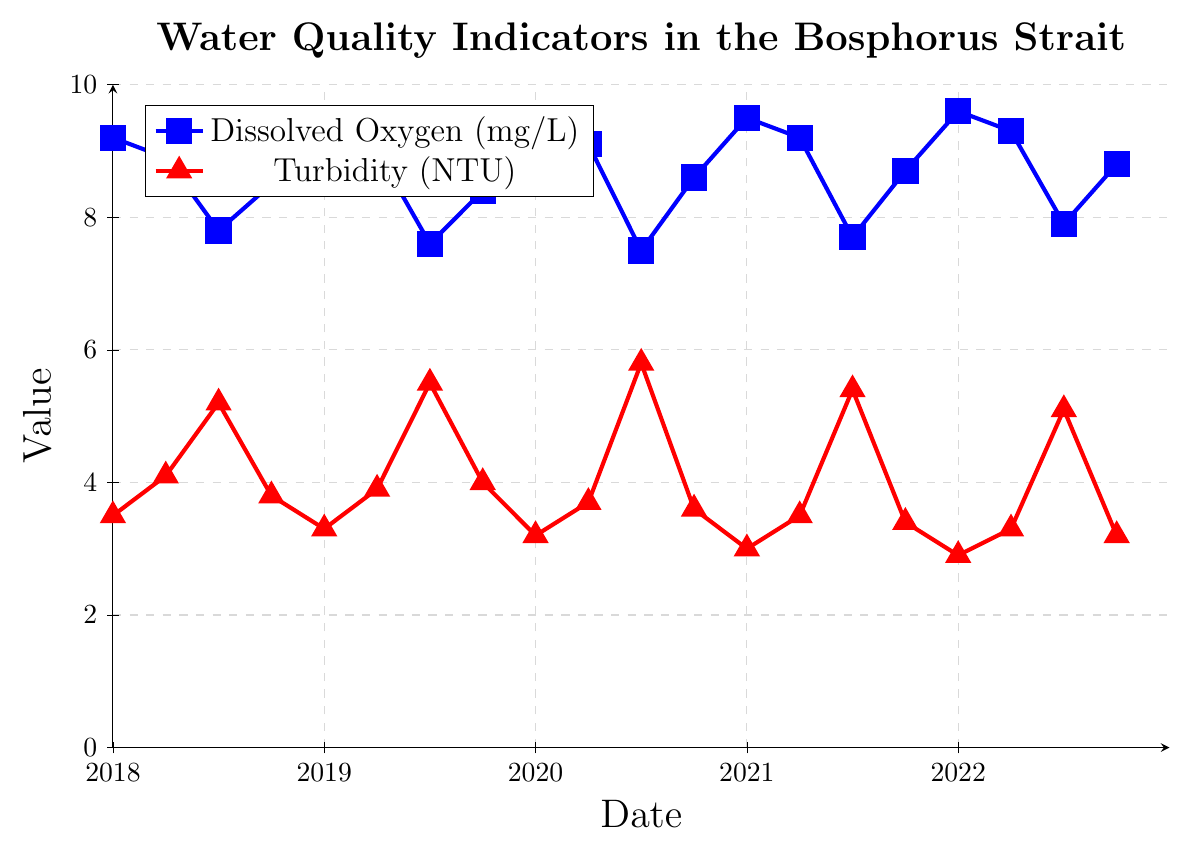Which year has the highest average dissolved oxygen values? To find the highest average dissolved oxygen values by year, we need to calculate the average for each year by summing the values for each year and dividing by the number of data points for that year. For 2018, the average is (9.2+8.9+7.8+8.5)/4 = 8.6 mg/L. For 2019, the average is (9.3+9.0+7.6+8.4)/4 = 8.575 mg/L. For 2020, the average is (9.4+9.1+7.5+8.6)/4 = 8.65 mg/L. For 2021, the average is (9.5+9.2+7.7+8.7)/4 = 8.775 mg/L. For 2022, the average is (9.6+9.3+7.9+8.8)/4 = 8.9 mg/L. Therefore, 2022 has the highest average dissolved oxygen.
Answer: 2022 Which quarter generally has the lowest turbidity values over the years? To identify the quarter with generally the lowest turbidity, we analyze the turbidity values for each quarter across all years: Q1 (January: 3.5, 3.3, 3.2, 3.0, 2.9), Q2 (April: 4.1, 3.9, 3.7, 3.5, 3.3), Q3 (July: 5.2, 5.5, 5.8, 5.4, 5.1), Q4 (October: 3.8, 4.0, 3.6, 3.4, 3.2). Q1 has the lowest values on average.
Answer: Q1 What is the difference in dissolved oxygen levels between July 2019 and July 2020? The dissolved oxygen level in July 2019 is 7.6 mg/L and in July 2020 is 7.5 mg/L. The difference is 7.6 - 7.5 = 0.1 mg/L.
Answer: 0.1 mg/L Which month and year saw the lowest dissolved oxygen value recorded? By scanning the dissolved oxygen data, we observe that the lowest value is 7.5 mg/L which occurred in July 2020.
Answer: July 2020 What is the overall trend in turbidity levels in October from 2018 to 2022? To identify the trend, we look at October turbidity values: 2018 (3.8 NTU), 2019 (4.0 NTU), 2020 (3.6 NTU), 2021 (3.4 NTU), 2022 (3.2 NTU). There is a downward trend in turbidity levels in October from 2018 to 2022.
Answer: Downward trend How does the dissolved oxygen level in October 2020 compare to April 2020? The dissolved oxygen level in October 2020 is 8.6 mg/L, while in April 2020 it is 9.1 mg/L. Comparing these values, October 2020 has lower dissolved oxygen than April 2020.
Answer: Lower What was the highest turbidity value recorded and in which month and year did it occur? By inspecting the turbidity values, the highest recorded is 5.8 NTU which took place in July 2020.
Answer: July 2020 Was there any year where the dissolved oxygen value did not exceed 9 mg/L for any month? To determine this, we check each year's dissolved oxygen values. All years from 2018 to 2022 show at least one month where the dissolved oxygen value exceeds 9 mg/L.
Answer: No 